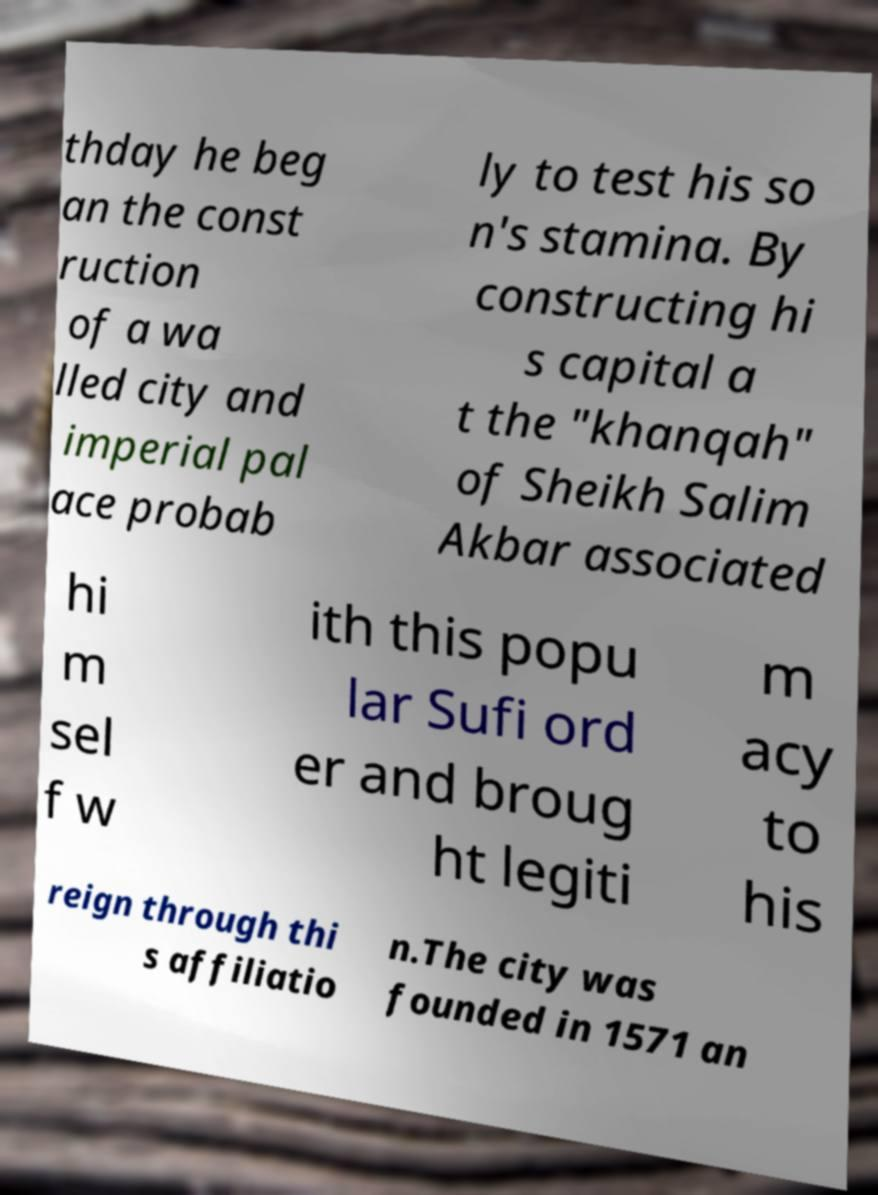Please read and relay the text visible in this image. What does it say? thday he beg an the const ruction of a wa lled city and imperial pal ace probab ly to test his so n's stamina. By constructing hi s capital a t the "khanqah" of Sheikh Salim Akbar associated hi m sel f w ith this popu lar Sufi ord er and broug ht legiti m acy to his reign through thi s affiliatio n.The city was founded in 1571 an 